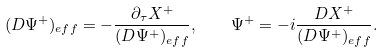<formula> <loc_0><loc_0><loc_500><loc_500>( D \Psi ^ { + } ) _ { e f f } = - { \frac { \partial _ { \tau } X ^ { + } } { ( D \Psi ^ { + } ) _ { e f f } } } , \quad \Psi ^ { + } = - i { \frac { D X ^ { + } } { ( D \Psi ^ { + } ) _ { e f f } } } .</formula> 